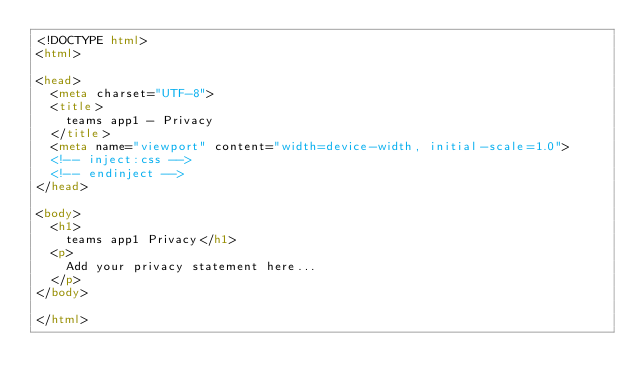Convert code to text. <code><loc_0><loc_0><loc_500><loc_500><_HTML_><!DOCTYPE html>
<html>

<head>
  <meta charset="UTF-8">
  <title>
    teams app1 - Privacy
  </title>
  <meta name="viewport" content="width=device-width, initial-scale=1.0">
  <!-- inject:css -->
  <!-- endinject -->
</head>

<body>
  <h1>
    teams app1 Privacy</h1>
  <p>
    Add your privacy statement here...
  </p>
</body>

</html></code> 